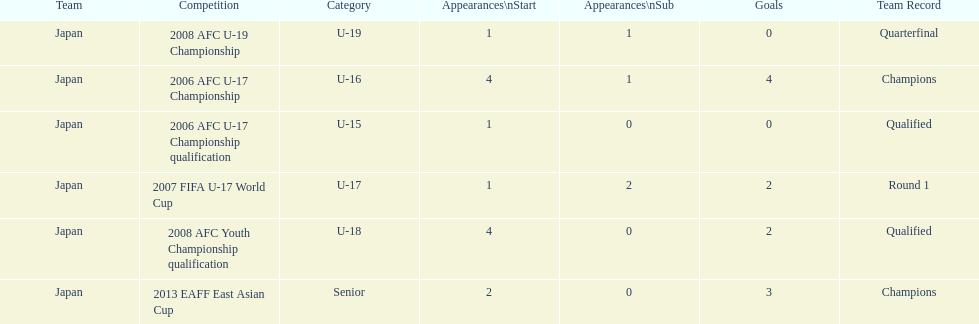How many total goals were scored? 11. 